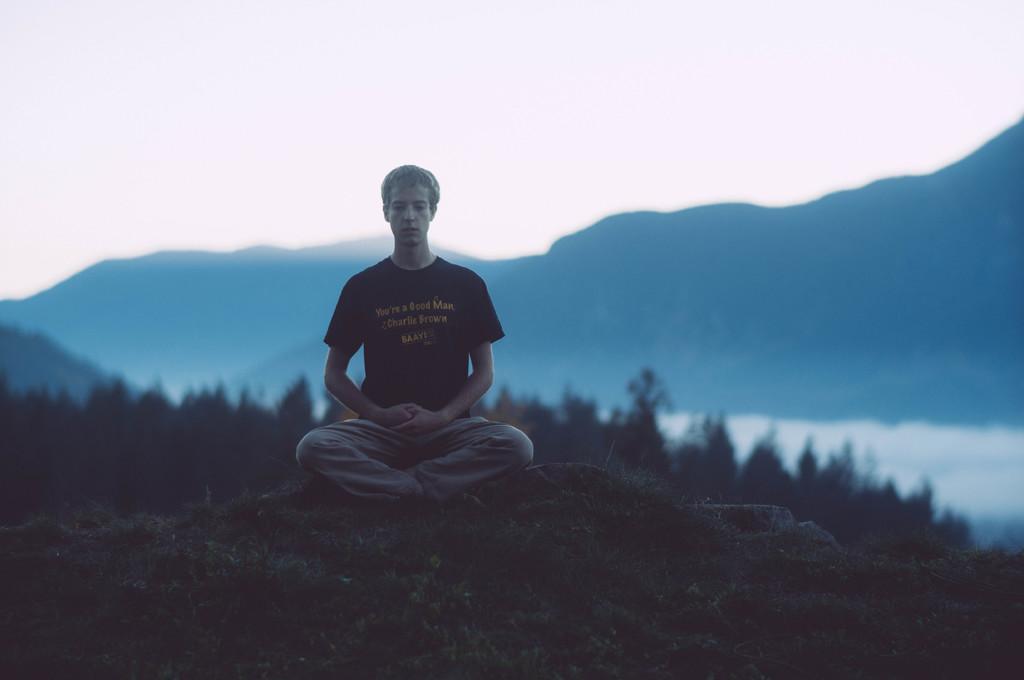Please provide a concise description of this image. In the image there is a man meditating on the hill and behind him there are hills and above its sky. 